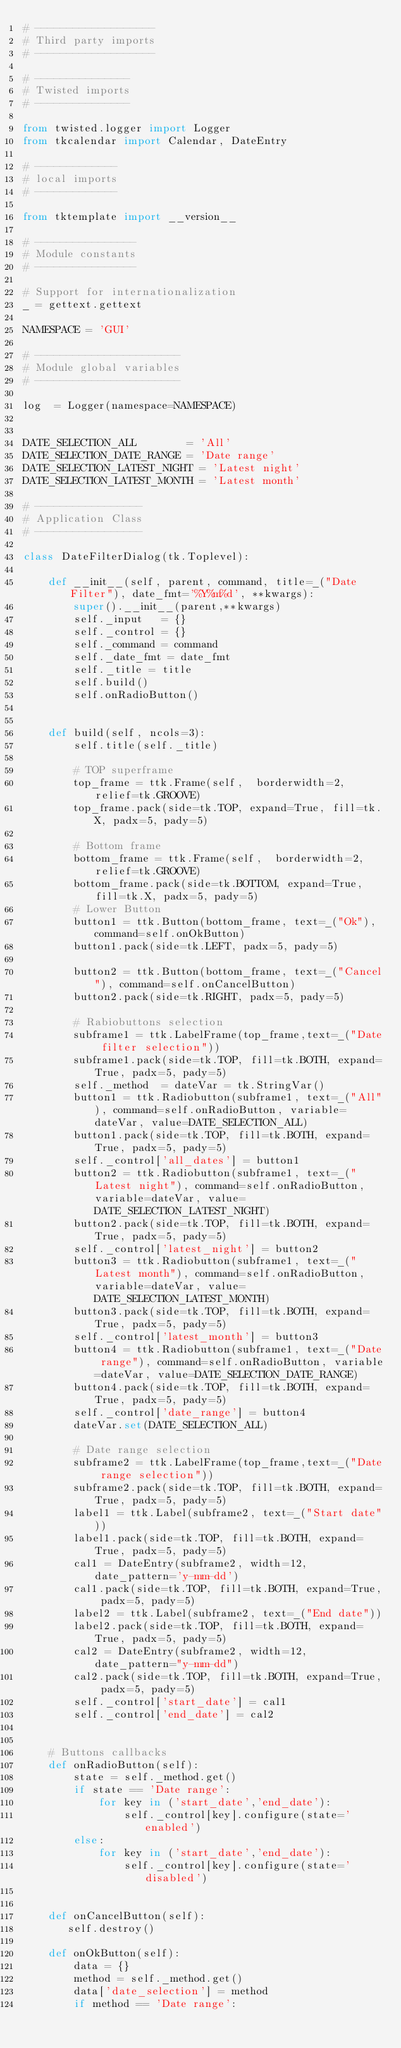Convert code to text. <code><loc_0><loc_0><loc_500><loc_500><_Python_># -------------------
# Third party imports
# -------------------

# ---------------
# Twisted imports
# ---------------

from twisted.logger import Logger
from tkcalendar import Calendar, DateEntry

# -------------
# local imports
# -------------

from tktemplate import __version__

# ----------------
# Module constants
# ----------------

# Support for internationalization
_ = gettext.gettext

NAMESPACE = 'GUI'

# -----------------------
# Module global variables
# -----------------------

log  = Logger(namespace=NAMESPACE)


DATE_SELECTION_ALL        = 'All'
DATE_SELECTION_DATE_RANGE = 'Date range'
DATE_SELECTION_LATEST_NIGHT = 'Latest night'
DATE_SELECTION_LATEST_MONTH = 'Latest month'

# -----------------
# Application Class
# -----------------

class DateFilterDialog(tk.Toplevel):

    def __init__(self, parent, command, title=_("Date Filter"), date_fmt='%Y%m%d', **kwargs):
        super().__init__(parent,**kwargs)
        self._input   = {}
        self._control = {}
        self._command = command
        self._date_fmt = date_fmt
        self._title = title
        self.build()
        self.onRadioButton()
        
        
    def build(self, ncols=3):
        self.title(self._title)

        # TOP superframe
        top_frame = ttk.Frame(self,  borderwidth=2, relief=tk.GROOVE)
        top_frame.pack(side=tk.TOP, expand=True, fill=tk.X, padx=5, pady=5)
        
        # Bottom frame
        bottom_frame = ttk.Frame(self,  borderwidth=2, relief=tk.GROOVE)
        bottom_frame.pack(side=tk.BOTTOM, expand=True, fill=tk.X, padx=5, pady=5)
        # Lower Button
        button1 = ttk.Button(bottom_frame, text=_("Ok"), command=self.onOkButton)
        button1.pack(side=tk.LEFT, padx=5, pady=5)

        button2 = ttk.Button(bottom_frame, text=_("Cancel"), command=self.onCancelButton)
        button2.pack(side=tk.RIGHT, padx=5, pady=5)

        # Rabiobuttons selection
        subframe1 = ttk.LabelFrame(top_frame,text=_("Date filter selection"))
        subframe1.pack(side=tk.TOP, fill=tk.BOTH, expand=True, padx=5, pady=5)
        self._method  = dateVar = tk.StringVar()
        button1 = ttk.Radiobutton(subframe1, text=_("All"), command=self.onRadioButton, variable=dateVar, value=DATE_SELECTION_ALL)
        button1.pack(side=tk.TOP, fill=tk.BOTH, expand=True, padx=5, pady=5)
        self._control['all_dates'] = button1
        button2 = ttk.Radiobutton(subframe1, text=_("Latest night"), command=self.onRadioButton, variable=dateVar, value=DATE_SELECTION_LATEST_NIGHT)
        button2.pack(side=tk.TOP, fill=tk.BOTH, expand=True, padx=5, pady=5)
        self._control['latest_night'] = button2
        button3 = ttk.Radiobutton(subframe1, text=_("Latest month"), command=self.onRadioButton, variable=dateVar, value=DATE_SELECTION_LATEST_MONTH)
        button3.pack(side=tk.TOP, fill=tk.BOTH, expand=True, padx=5, pady=5)
        self._control['latest_month'] = button3
        button4 = ttk.Radiobutton(subframe1, text=_("Date range"), command=self.onRadioButton, variable=dateVar, value=DATE_SELECTION_DATE_RANGE)
        button4.pack(side=tk.TOP, fill=tk.BOTH, expand=True, padx=5, pady=5)
        self._control['date_range'] = button4
        dateVar.set(DATE_SELECTION_ALL)

        # Date range selection
        subframe2 = ttk.LabelFrame(top_frame,text=_("Date range selection"))
        subframe2.pack(side=tk.TOP, fill=tk.BOTH, expand=True, padx=5, pady=5)
        label1 = ttk.Label(subframe2, text=_("Start date"))
        label1.pack(side=tk.TOP, fill=tk.BOTH, expand=True, padx=5, pady=5)
        cal1 = DateEntry(subframe2, width=12, date_pattern='y-mm-dd')
        cal1.pack(side=tk.TOP, fill=tk.BOTH, expand=True, padx=5, pady=5)
        label2 = ttk.Label(subframe2, text=_("End date"))
        label2.pack(side=tk.TOP, fill=tk.BOTH, expand=True, padx=5, pady=5)
        cal2 = DateEntry(subframe2, width=12, date_pattern="y-mm-dd")
        cal2.pack(side=tk.TOP, fill=tk.BOTH, expand=True, padx=5, pady=5)
        self._control['start_date'] = cal1
        self._control['end_date'] = cal2


    # Buttons callbacks
    def onRadioButton(self):
        state = self._method.get()
        if state == 'Date range':
            for key in ('start_date','end_date'):
                self._control[key].configure(state='enabled')
        else:
            for key in ('start_date','end_date'):
                self._control[key].configure(state='disabled')
        

    def onCancelButton(self):
       self.destroy()

    def onOkButton(self):
        data = {}
        method = self._method.get()
        data['date_selection'] = method
        if method == 'Date range':</code> 